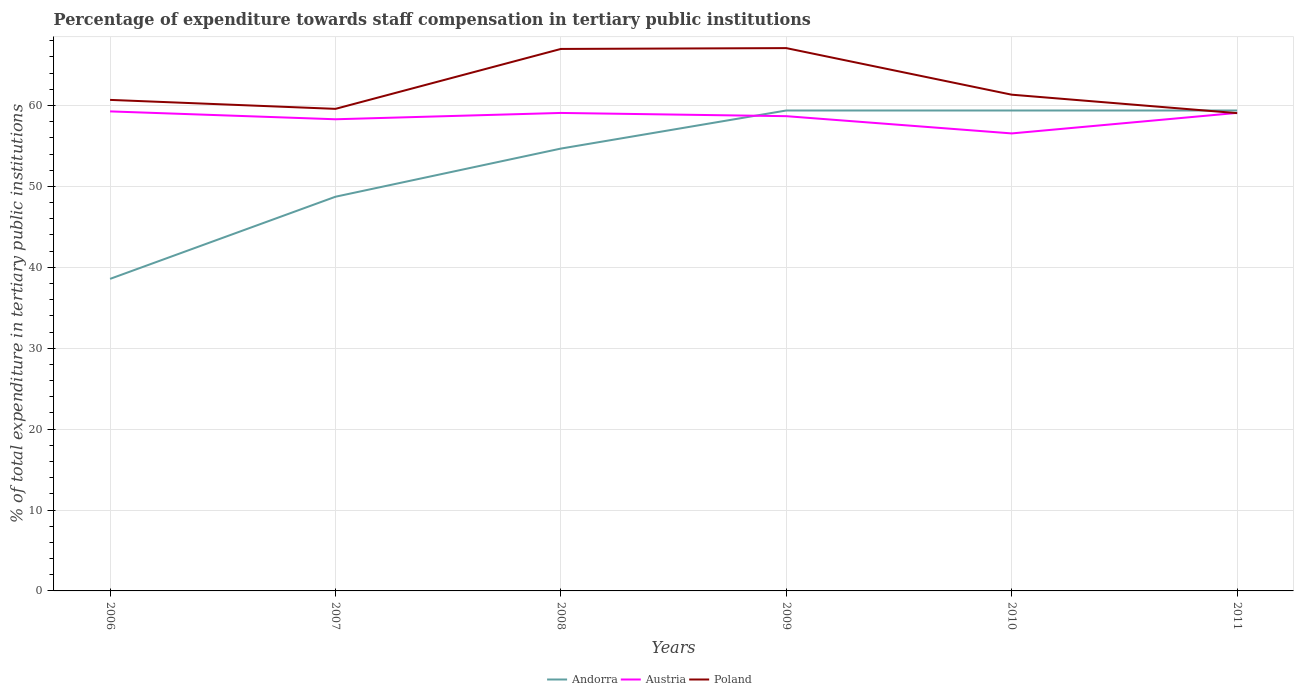Does the line corresponding to Austria intersect with the line corresponding to Andorra?
Give a very brief answer. Yes. Across all years, what is the maximum percentage of expenditure towards staff compensation in Austria?
Make the answer very short. 56.54. What is the total percentage of expenditure towards staff compensation in Andorra in the graph?
Ensure brevity in your answer.  -20.81. What is the difference between the highest and the second highest percentage of expenditure towards staff compensation in Austria?
Your answer should be compact. 2.72. What is the difference between the highest and the lowest percentage of expenditure towards staff compensation in Poland?
Give a very brief answer. 2. How many years are there in the graph?
Offer a terse response. 6. What is the difference between two consecutive major ticks on the Y-axis?
Give a very brief answer. 10. Does the graph contain grids?
Ensure brevity in your answer.  Yes. How are the legend labels stacked?
Keep it short and to the point. Horizontal. What is the title of the graph?
Your answer should be very brief. Percentage of expenditure towards staff compensation in tertiary public institutions. What is the label or title of the Y-axis?
Make the answer very short. % of total expenditure in tertiary public institutions. What is the % of total expenditure in tertiary public institutions of Andorra in 2006?
Your answer should be very brief. 38.57. What is the % of total expenditure in tertiary public institutions in Austria in 2006?
Provide a short and direct response. 59.27. What is the % of total expenditure in tertiary public institutions in Poland in 2006?
Provide a short and direct response. 60.69. What is the % of total expenditure in tertiary public institutions of Andorra in 2007?
Your answer should be compact. 48.72. What is the % of total expenditure in tertiary public institutions of Austria in 2007?
Your response must be concise. 58.29. What is the % of total expenditure in tertiary public institutions of Poland in 2007?
Keep it short and to the point. 59.58. What is the % of total expenditure in tertiary public institutions in Andorra in 2008?
Offer a very short reply. 54.67. What is the % of total expenditure in tertiary public institutions of Austria in 2008?
Offer a very short reply. 59.08. What is the % of total expenditure in tertiary public institutions in Poland in 2008?
Provide a short and direct response. 66.99. What is the % of total expenditure in tertiary public institutions of Andorra in 2009?
Provide a succinct answer. 59.38. What is the % of total expenditure in tertiary public institutions in Austria in 2009?
Your answer should be very brief. 58.68. What is the % of total expenditure in tertiary public institutions of Poland in 2009?
Your answer should be very brief. 67.09. What is the % of total expenditure in tertiary public institutions in Andorra in 2010?
Your response must be concise. 59.38. What is the % of total expenditure in tertiary public institutions in Austria in 2010?
Ensure brevity in your answer.  56.54. What is the % of total expenditure in tertiary public institutions in Poland in 2010?
Make the answer very short. 61.33. What is the % of total expenditure in tertiary public institutions of Andorra in 2011?
Your answer should be very brief. 59.38. What is the % of total expenditure in tertiary public institutions in Austria in 2011?
Keep it short and to the point. 59.08. What is the % of total expenditure in tertiary public institutions in Poland in 2011?
Make the answer very short. 59.05. Across all years, what is the maximum % of total expenditure in tertiary public institutions of Andorra?
Provide a succinct answer. 59.38. Across all years, what is the maximum % of total expenditure in tertiary public institutions of Austria?
Make the answer very short. 59.27. Across all years, what is the maximum % of total expenditure in tertiary public institutions in Poland?
Offer a terse response. 67.09. Across all years, what is the minimum % of total expenditure in tertiary public institutions in Andorra?
Provide a succinct answer. 38.57. Across all years, what is the minimum % of total expenditure in tertiary public institutions in Austria?
Give a very brief answer. 56.54. Across all years, what is the minimum % of total expenditure in tertiary public institutions in Poland?
Your response must be concise. 59.05. What is the total % of total expenditure in tertiary public institutions in Andorra in the graph?
Your answer should be compact. 320.09. What is the total % of total expenditure in tertiary public institutions of Austria in the graph?
Keep it short and to the point. 350.94. What is the total % of total expenditure in tertiary public institutions in Poland in the graph?
Offer a very short reply. 374.73. What is the difference between the % of total expenditure in tertiary public institutions in Andorra in 2006 and that in 2007?
Provide a short and direct response. -10.15. What is the difference between the % of total expenditure in tertiary public institutions in Austria in 2006 and that in 2007?
Your answer should be compact. 0.97. What is the difference between the % of total expenditure in tertiary public institutions in Poland in 2006 and that in 2007?
Ensure brevity in your answer.  1.11. What is the difference between the % of total expenditure in tertiary public institutions of Andorra in 2006 and that in 2008?
Ensure brevity in your answer.  -16.1. What is the difference between the % of total expenditure in tertiary public institutions in Austria in 2006 and that in 2008?
Offer a very short reply. 0.19. What is the difference between the % of total expenditure in tertiary public institutions in Poland in 2006 and that in 2008?
Offer a very short reply. -6.3. What is the difference between the % of total expenditure in tertiary public institutions in Andorra in 2006 and that in 2009?
Give a very brief answer. -20.81. What is the difference between the % of total expenditure in tertiary public institutions of Austria in 2006 and that in 2009?
Make the answer very short. 0.59. What is the difference between the % of total expenditure in tertiary public institutions of Poland in 2006 and that in 2009?
Keep it short and to the point. -6.4. What is the difference between the % of total expenditure in tertiary public institutions of Andorra in 2006 and that in 2010?
Your response must be concise. -20.81. What is the difference between the % of total expenditure in tertiary public institutions of Austria in 2006 and that in 2010?
Ensure brevity in your answer.  2.72. What is the difference between the % of total expenditure in tertiary public institutions in Poland in 2006 and that in 2010?
Provide a succinct answer. -0.64. What is the difference between the % of total expenditure in tertiary public institutions in Andorra in 2006 and that in 2011?
Give a very brief answer. -20.81. What is the difference between the % of total expenditure in tertiary public institutions in Austria in 2006 and that in 2011?
Provide a short and direct response. 0.19. What is the difference between the % of total expenditure in tertiary public institutions in Poland in 2006 and that in 2011?
Your response must be concise. 1.64. What is the difference between the % of total expenditure in tertiary public institutions of Andorra in 2007 and that in 2008?
Offer a very short reply. -5.95. What is the difference between the % of total expenditure in tertiary public institutions of Austria in 2007 and that in 2008?
Offer a very short reply. -0.78. What is the difference between the % of total expenditure in tertiary public institutions of Poland in 2007 and that in 2008?
Your answer should be compact. -7.41. What is the difference between the % of total expenditure in tertiary public institutions of Andorra in 2007 and that in 2009?
Your response must be concise. -10.66. What is the difference between the % of total expenditure in tertiary public institutions of Austria in 2007 and that in 2009?
Your answer should be very brief. -0.38. What is the difference between the % of total expenditure in tertiary public institutions in Poland in 2007 and that in 2009?
Provide a short and direct response. -7.51. What is the difference between the % of total expenditure in tertiary public institutions in Andorra in 2007 and that in 2010?
Give a very brief answer. -10.66. What is the difference between the % of total expenditure in tertiary public institutions of Austria in 2007 and that in 2010?
Keep it short and to the point. 1.75. What is the difference between the % of total expenditure in tertiary public institutions in Poland in 2007 and that in 2010?
Provide a succinct answer. -1.75. What is the difference between the % of total expenditure in tertiary public institutions in Andorra in 2007 and that in 2011?
Keep it short and to the point. -10.66. What is the difference between the % of total expenditure in tertiary public institutions of Austria in 2007 and that in 2011?
Offer a very short reply. -0.79. What is the difference between the % of total expenditure in tertiary public institutions of Poland in 2007 and that in 2011?
Ensure brevity in your answer.  0.53. What is the difference between the % of total expenditure in tertiary public institutions in Andorra in 2008 and that in 2009?
Give a very brief answer. -4.71. What is the difference between the % of total expenditure in tertiary public institutions in Austria in 2008 and that in 2009?
Keep it short and to the point. 0.4. What is the difference between the % of total expenditure in tertiary public institutions of Poland in 2008 and that in 2009?
Give a very brief answer. -0.1. What is the difference between the % of total expenditure in tertiary public institutions of Andorra in 2008 and that in 2010?
Your answer should be compact. -4.71. What is the difference between the % of total expenditure in tertiary public institutions of Austria in 2008 and that in 2010?
Provide a short and direct response. 2.53. What is the difference between the % of total expenditure in tertiary public institutions of Poland in 2008 and that in 2010?
Provide a short and direct response. 5.66. What is the difference between the % of total expenditure in tertiary public institutions in Andorra in 2008 and that in 2011?
Make the answer very short. -4.71. What is the difference between the % of total expenditure in tertiary public institutions of Austria in 2008 and that in 2011?
Your answer should be compact. -0. What is the difference between the % of total expenditure in tertiary public institutions in Poland in 2008 and that in 2011?
Your response must be concise. 7.94. What is the difference between the % of total expenditure in tertiary public institutions in Austria in 2009 and that in 2010?
Make the answer very short. 2.13. What is the difference between the % of total expenditure in tertiary public institutions of Poland in 2009 and that in 2010?
Offer a terse response. 5.76. What is the difference between the % of total expenditure in tertiary public institutions of Austria in 2009 and that in 2011?
Your answer should be compact. -0.4. What is the difference between the % of total expenditure in tertiary public institutions in Poland in 2009 and that in 2011?
Your response must be concise. 8.04. What is the difference between the % of total expenditure in tertiary public institutions of Austria in 2010 and that in 2011?
Give a very brief answer. -2.54. What is the difference between the % of total expenditure in tertiary public institutions of Poland in 2010 and that in 2011?
Make the answer very short. 2.28. What is the difference between the % of total expenditure in tertiary public institutions of Andorra in 2006 and the % of total expenditure in tertiary public institutions of Austria in 2007?
Make the answer very short. -19.73. What is the difference between the % of total expenditure in tertiary public institutions of Andorra in 2006 and the % of total expenditure in tertiary public institutions of Poland in 2007?
Your response must be concise. -21.01. What is the difference between the % of total expenditure in tertiary public institutions of Austria in 2006 and the % of total expenditure in tertiary public institutions of Poland in 2007?
Provide a short and direct response. -0.31. What is the difference between the % of total expenditure in tertiary public institutions of Andorra in 2006 and the % of total expenditure in tertiary public institutions of Austria in 2008?
Your response must be concise. -20.51. What is the difference between the % of total expenditure in tertiary public institutions in Andorra in 2006 and the % of total expenditure in tertiary public institutions in Poland in 2008?
Ensure brevity in your answer.  -28.42. What is the difference between the % of total expenditure in tertiary public institutions in Austria in 2006 and the % of total expenditure in tertiary public institutions in Poland in 2008?
Give a very brief answer. -7.72. What is the difference between the % of total expenditure in tertiary public institutions in Andorra in 2006 and the % of total expenditure in tertiary public institutions in Austria in 2009?
Your answer should be compact. -20.11. What is the difference between the % of total expenditure in tertiary public institutions in Andorra in 2006 and the % of total expenditure in tertiary public institutions in Poland in 2009?
Provide a succinct answer. -28.52. What is the difference between the % of total expenditure in tertiary public institutions of Austria in 2006 and the % of total expenditure in tertiary public institutions of Poland in 2009?
Your answer should be compact. -7.82. What is the difference between the % of total expenditure in tertiary public institutions of Andorra in 2006 and the % of total expenditure in tertiary public institutions of Austria in 2010?
Provide a short and direct response. -17.98. What is the difference between the % of total expenditure in tertiary public institutions in Andorra in 2006 and the % of total expenditure in tertiary public institutions in Poland in 2010?
Offer a terse response. -22.76. What is the difference between the % of total expenditure in tertiary public institutions of Austria in 2006 and the % of total expenditure in tertiary public institutions of Poland in 2010?
Provide a succinct answer. -2.06. What is the difference between the % of total expenditure in tertiary public institutions of Andorra in 2006 and the % of total expenditure in tertiary public institutions of Austria in 2011?
Provide a succinct answer. -20.51. What is the difference between the % of total expenditure in tertiary public institutions of Andorra in 2006 and the % of total expenditure in tertiary public institutions of Poland in 2011?
Provide a short and direct response. -20.48. What is the difference between the % of total expenditure in tertiary public institutions of Austria in 2006 and the % of total expenditure in tertiary public institutions of Poland in 2011?
Provide a succinct answer. 0.22. What is the difference between the % of total expenditure in tertiary public institutions in Andorra in 2007 and the % of total expenditure in tertiary public institutions in Austria in 2008?
Your answer should be very brief. -10.36. What is the difference between the % of total expenditure in tertiary public institutions in Andorra in 2007 and the % of total expenditure in tertiary public institutions in Poland in 2008?
Your answer should be compact. -18.27. What is the difference between the % of total expenditure in tertiary public institutions of Austria in 2007 and the % of total expenditure in tertiary public institutions of Poland in 2008?
Provide a succinct answer. -8.69. What is the difference between the % of total expenditure in tertiary public institutions of Andorra in 2007 and the % of total expenditure in tertiary public institutions of Austria in 2009?
Your answer should be very brief. -9.96. What is the difference between the % of total expenditure in tertiary public institutions in Andorra in 2007 and the % of total expenditure in tertiary public institutions in Poland in 2009?
Your response must be concise. -18.37. What is the difference between the % of total expenditure in tertiary public institutions of Austria in 2007 and the % of total expenditure in tertiary public institutions of Poland in 2009?
Keep it short and to the point. -8.79. What is the difference between the % of total expenditure in tertiary public institutions of Andorra in 2007 and the % of total expenditure in tertiary public institutions of Austria in 2010?
Your response must be concise. -7.82. What is the difference between the % of total expenditure in tertiary public institutions in Andorra in 2007 and the % of total expenditure in tertiary public institutions in Poland in 2010?
Keep it short and to the point. -12.61. What is the difference between the % of total expenditure in tertiary public institutions of Austria in 2007 and the % of total expenditure in tertiary public institutions of Poland in 2010?
Ensure brevity in your answer.  -3.04. What is the difference between the % of total expenditure in tertiary public institutions in Andorra in 2007 and the % of total expenditure in tertiary public institutions in Austria in 2011?
Offer a terse response. -10.36. What is the difference between the % of total expenditure in tertiary public institutions in Andorra in 2007 and the % of total expenditure in tertiary public institutions in Poland in 2011?
Give a very brief answer. -10.33. What is the difference between the % of total expenditure in tertiary public institutions in Austria in 2007 and the % of total expenditure in tertiary public institutions in Poland in 2011?
Make the answer very short. -0.76. What is the difference between the % of total expenditure in tertiary public institutions of Andorra in 2008 and the % of total expenditure in tertiary public institutions of Austria in 2009?
Offer a terse response. -4. What is the difference between the % of total expenditure in tertiary public institutions in Andorra in 2008 and the % of total expenditure in tertiary public institutions in Poland in 2009?
Ensure brevity in your answer.  -12.42. What is the difference between the % of total expenditure in tertiary public institutions of Austria in 2008 and the % of total expenditure in tertiary public institutions of Poland in 2009?
Your answer should be very brief. -8.01. What is the difference between the % of total expenditure in tertiary public institutions in Andorra in 2008 and the % of total expenditure in tertiary public institutions in Austria in 2010?
Provide a short and direct response. -1.87. What is the difference between the % of total expenditure in tertiary public institutions of Andorra in 2008 and the % of total expenditure in tertiary public institutions of Poland in 2010?
Give a very brief answer. -6.66. What is the difference between the % of total expenditure in tertiary public institutions of Austria in 2008 and the % of total expenditure in tertiary public institutions of Poland in 2010?
Your answer should be very brief. -2.25. What is the difference between the % of total expenditure in tertiary public institutions of Andorra in 2008 and the % of total expenditure in tertiary public institutions of Austria in 2011?
Ensure brevity in your answer.  -4.41. What is the difference between the % of total expenditure in tertiary public institutions in Andorra in 2008 and the % of total expenditure in tertiary public institutions in Poland in 2011?
Your answer should be very brief. -4.38. What is the difference between the % of total expenditure in tertiary public institutions in Austria in 2008 and the % of total expenditure in tertiary public institutions in Poland in 2011?
Your answer should be very brief. 0.03. What is the difference between the % of total expenditure in tertiary public institutions in Andorra in 2009 and the % of total expenditure in tertiary public institutions in Austria in 2010?
Make the answer very short. 2.83. What is the difference between the % of total expenditure in tertiary public institutions of Andorra in 2009 and the % of total expenditure in tertiary public institutions of Poland in 2010?
Your answer should be compact. -1.95. What is the difference between the % of total expenditure in tertiary public institutions of Austria in 2009 and the % of total expenditure in tertiary public institutions of Poland in 2010?
Make the answer very short. -2.65. What is the difference between the % of total expenditure in tertiary public institutions of Andorra in 2009 and the % of total expenditure in tertiary public institutions of Austria in 2011?
Ensure brevity in your answer.  0.3. What is the difference between the % of total expenditure in tertiary public institutions of Andorra in 2009 and the % of total expenditure in tertiary public institutions of Poland in 2011?
Provide a succinct answer. 0.33. What is the difference between the % of total expenditure in tertiary public institutions in Austria in 2009 and the % of total expenditure in tertiary public institutions in Poland in 2011?
Your answer should be very brief. -0.37. What is the difference between the % of total expenditure in tertiary public institutions of Andorra in 2010 and the % of total expenditure in tertiary public institutions of Austria in 2011?
Your response must be concise. 0.3. What is the difference between the % of total expenditure in tertiary public institutions of Andorra in 2010 and the % of total expenditure in tertiary public institutions of Poland in 2011?
Provide a short and direct response. 0.33. What is the difference between the % of total expenditure in tertiary public institutions in Austria in 2010 and the % of total expenditure in tertiary public institutions in Poland in 2011?
Offer a terse response. -2.51. What is the average % of total expenditure in tertiary public institutions in Andorra per year?
Make the answer very short. 53.35. What is the average % of total expenditure in tertiary public institutions of Austria per year?
Your answer should be very brief. 58.49. What is the average % of total expenditure in tertiary public institutions of Poland per year?
Provide a succinct answer. 62.45. In the year 2006, what is the difference between the % of total expenditure in tertiary public institutions in Andorra and % of total expenditure in tertiary public institutions in Austria?
Provide a short and direct response. -20.7. In the year 2006, what is the difference between the % of total expenditure in tertiary public institutions of Andorra and % of total expenditure in tertiary public institutions of Poland?
Offer a terse response. -22.12. In the year 2006, what is the difference between the % of total expenditure in tertiary public institutions in Austria and % of total expenditure in tertiary public institutions in Poland?
Ensure brevity in your answer.  -1.42. In the year 2007, what is the difference between the % of total expenditure in tertiary public institutions of Andorra and % of total expenditure in tertiary public institutions of Austria?
Your answer should be compact. -9.57. In the year 2007, what is the difference between the % of total expenditure in tertiary public institutions of Andorra and % of total expenditure in tertiary public institutions of Poland?
Provide a succinct answer. -10.86. In the year 2007, what is the difference between the % of total expenditure in tertiary public institutions in Austria and % of total expenditure in tertiary public institutions in Poland?
Give a very brief answer. -1.29. In the year 2008, what is the difference between the % of total expenditure in tertiary public institutions in Andorra and % of total expenditure in tertiary public institutions in Austria?
Make the answer very short. -4.4. In the year 2008, what is the difference between the % of total expenditure in tertiary public institutions of Andorra and % of total expenditure in tertiary public institutions of Poland?
Provide a short and direct response. -12.31. In the year 2008, what is the difference between the % of total expenditure in tertiary public institutions in Austria and % of total expenditure in tertiary public institutions in Poland?
Your answer should be very brief. -7.91. In the year 2009, what is the difference between the % of total expenditure in tertiary public institutions in Andorra and % of total expenditure in tertiary public institutions in Austria?
Offer a very short reply. 0.7. In the year 2009, what is the difference between the % of total expenditure in tertiary public institutions in Andorra and % of total expenditure in tertiary public institutions in Poland?
Ensure brevity in your answer.  -7.71. In the year 2009, what is the difference between the % of total expenditure in tertiary public institutions in Austria and % of total expenditure in tertiary public institutions in Poland?
Your response must be concise. -8.41. In the year 2010, what is the difference between the % of total expenditure in tertiary public institutions of Andorra and % of total expenditure in tertiary public institutions of Austria?
Keep it short and to the point. 2.83. In the year 2010, what is the difference between the % of total expenditure in tertiary public institutions of Andorra and % of total expenditure in tertiary public institutions of Poland?
Provide a short and direct response. -1.95. In the year 2010, what is the difference between the % of total expenditure in tertiary public institutions of Austria and % of total expenditure in tertiary public institutions of Poland?
Keep it short and to the point. -4.79. In the year 2011, what is the difference between the % of total expenditure in tertiary public institutions in Andorra and % of total expenditure in tertiary public institutions in Austria?
Keep it short and to the point. 0.3. In the year 2011, what is the difference between the % of total expenditure in tertiary public institutions in Andorra and % of total expenditure in tertiary public institutions in Poland?
Provide a short and direct response. 0.33. In the year 2011, what is the difference between the % of total expenditure in tertiary public institutions of Austria and % of total expenditure in tertiary public institutions of Poland?
Offer a very short reply. 0.03. What is the ratio of the % of total expenditure in tertiary public institutions of Andorra in 2006 to that in 2007?
Offer a very short reply. 0.79. What is the ratio of the % of total expenditure in tertiary public institutions of Austria in 2006 to that in 2007?
Your answer should be compact. 1.02. What is the ratio of the % of total expenditure in tertiary public institutions in Poland in 2006 to that in 2007?
Provide a short and direct response. 1.02. What is the ratio of the % of total expenditure in tertiary public institutions of Andorra in 2006 to that in 2008?
Keep it short and to the point. 0.71. What is the ratio of the % of total expenditure in tertiary public institutions of Poland in 2006 to that in 2008?
Your answer should be very brief. 0.91. What is the ratio of the % of total expenditure in tertiary public institutions in Andorra in 2006 to that in 2009?
Make the answer very short. 0.65. What is the ratio of the % of total expenditure in tertiary public institutions of Poland in 2006 to that in 2009?
Offer a very short reply. 0.9. What is the ratio of the % of total expenditure in tertiary public institutions of Andorra in 2006 to that in 2010?
Your answer should be very brief. 0.65. What is the ratio of the % of total expenditure in tertiary public institutions of Austria in 2006 to that in 2010?
Provide a succinct answer. 1.05. What is the ratio of the % of total expenditure in tertiary public institutions of Poland in 2006 to that in 2010?
Your answer should be very brief. 0.99. What is the ratio of the % of total expenditure in tertiary public institutions of Andorra in 2006 to that in 2011?
Your response must be concise. 0.65. What is the ratio of the % of total expenditure in tertiary public institutions in Poland in 2006 to that in 2011?
Provide a short and direct response. 1.03. What is the ratio of the % of total expenditure in tertiary public institutions of Andorra in 2007 to that in 2008?
Your answer should be compact. 0.89. What is the ratio of the % of total expenditure in tertiary public institutions of Austria in 2007 to that in 2008?
Provide a short and direct response. 0.99. What is the ratio of the % of total expenditure in tertiary public institutions in Poland in 2007 to that in 2008?
Provide a succinct answer. 0.89. What is the ratio of the % of total expenditure in tertiary public institutions of Andorra in 2007 to that in 2009?
Keep it short and to the point. 0.82. What is the ratio of the % of total expenditure in tertiary public institutions in Austria in 2007 to that in 2009?
Offer a terse response. 0.99. What is the ratio of the % of total expenditure in tertiary public institutions in Poland in 2007 to that in 2009?
Provide a succinct answer. 0.89. What is the ratio of the % of total expenditure in tertiary public institutions of Andorra in 2007 to that in 2010?
Ensure brevity in your answer.  0.82. What is the ratio of the % of total expenditure in tertiary public institutions in Austria in 2007 to that in 2010?
Provide a succinct answer. 1.03. What is the ratio of the % of total expenditure in tertiary public institutions of Poland in 2007 to that in 2010?
Give a very brief answer. 0.97. What is the ratio of the % of total expenditure in tertiary public institutions of Andorra in 2007 to that in 2011?
Offer a very short reply. 0.82. What is the ratio of the % of total expenditure in tertiary public institutions in Austria in 2007 to that in 2011?
Give a very brief answer. 0.99. What is the ratio of the % of total expenditure in tertiary public institutions of Andorra in 2008 to that in 2009?
Provide a succinct answer. 0.92. What is the ratio of the % of total expenditure in tertiary public institutions in Austria in 2008 to that in 2009?
Offer a very short reply. 1.01. What is the ratio of the % of total expenditure in tertiary public institutions in Poland in 2008 to that in 2009?
Your answer should be compact. 1. What is the ratio of the % of total expenditure in tertiary public institutions in Andorra in 2008 to that in 2010?
Keep it short and to the point. 0.92. What is the ratio of the % of total expenditure in tertiary public institutions in Austria in 2008 to that in 2010?
Your answer should be compact. 1.04. What is the ratio of the % of total expenditure in tertiary public institutions of Poland in 2008 to that in 2010?
Make the answer very short. 1.09. What is the ratio of the % of total expenditure in tertiary public institutions in Andorra in 2008 to that in 2011?
Keep it short and to the point. 0.92. What is the ratio of the % of total expenditure in tertiary public institutions of Austria in 2008 to that in 2011?
Keep it short and to the point. 1. What is the ratio of the % of total expenditure in tertiary public institutions of Poland in 2008 to that in 2011?
Offer a very short reply. 1.13. What is the ratio of the % of total expenditure in tertiary public institutions in Andorra in 2009 to that in 2010?
Your answer should be compact. 1. What is the ratio of the % of total expenditure in tertiary public institutions of Austria in 2009 to that in 2010?
Ensure brevity in your answer.  1.04. What is the ratio of the % of total expenditure in tertiary public institutions of Poland in 2009 to that in 2010?
Your response must be concise. 1.09. What is the ratio of the % of total expenditure in tertiary public institutions in Austria in 2009 to that in 2011?
Keep it short and to the point. 0.99. What is the ratio of the % of total expenditure in tertiary public institutions in Poland in 2009 to that in 2011?
Make the answer very short. 1.14. What is the ratio of the % of total expenditure in tertiary public institutions in Poland in 2010 to that in 2011?
Ensure brevity in your answer.  1.04. What is the difference between the highest and the second highest % of total expenditure in tertiary public institutions of Austria?
Provide a short and direct response. 0.19. What is the difference between the highest and the second highest % of total expenditure in tertiary public institutions in Poland?
Keep it short and to the point. 0.1. What is the difference between the highest and the lowest % of total expenditure in tertiary public institutions in Andorra?
Give a very brief answer. 20.81. What is the difference between the highest and the lowest % of total expenditure in tertiary public institutions in Austria?
Ensure brevity in your answer.  2.72. What is the difference between the highest and the lowest % of total expenditure in tertiary public institutions in Poland?
Your answer should be very brief. 8.04. 